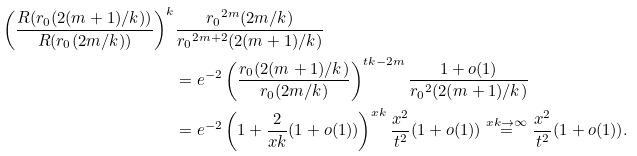<formula> <loc_0><loc_0><loc_500><loc_500>\left ( \frac { R ( r _ { 0 } ( 2 ( m + 1 ) / k ) ) } { R ( r _ { 0 } ( 2 m / k ) ) } \right ) ^ { k } & \frac { { r _ { 0 } } ^ { 2 m } ( 2 m / k ) } { { r _ { 0 } } ^ { 2 m + 2 } ( 2 ( m + 1 ) / k ) } \\ & = e ^ { - 2 } \left ( \frac { r _ { 0 } ( 2 ( m + 1 ) / k ) } { r _ { 0 } ( 2 m / k ) } \right ) ^ { t k - 2 m } \frac { 1 + o ( 1 ) } { { r _ { 0 } } ^ { 2 } ( 2 ( m + 1 ) / k ) } \\ & = e ^ { - 2 } \left ( 1 + \frac { 2 } { x k } ( 1 + o ( 1 ) ) \right ) ^ { x k } \frac { x ^ { 2 } } { t ^ { 2 } } ( 1 + o ( 1 ) ) \stackrel { x k \to \infty } { = } \frac { x ^ { 2 } } { t ^ { 2 } } ( 1 + o ( 1 ) ) .</formula> 